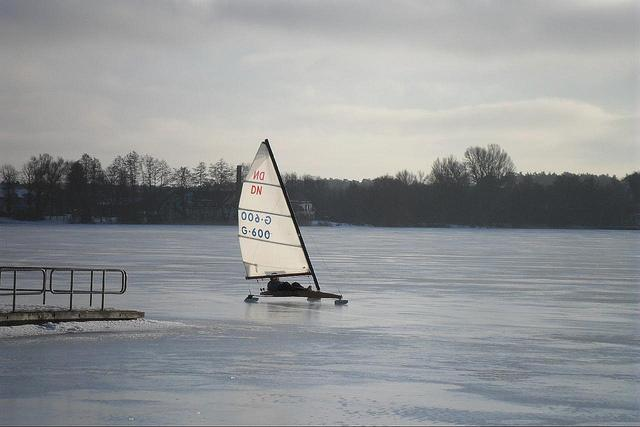In which manner does this vehicle move? Please explain your reasoning. sliding. A boat is shown in the water. boats slide across the water as they move. 